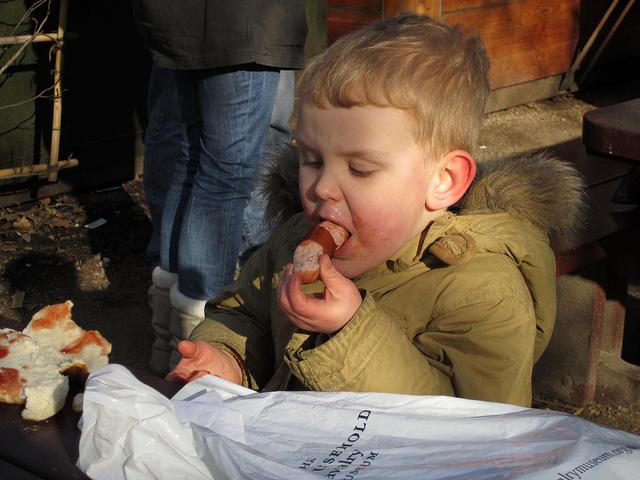Are these bags of stuffed animals?
Quick response, please. No. What is the child sitting on?
Give a very brief answer. Chair. Does the boy look like he likes this food?
Write a very short answer. Yes. What food is the child eating?
Concise answer only. Hot dog. Does the boy's jacket have a hood?
Concise answer only. Yes. 